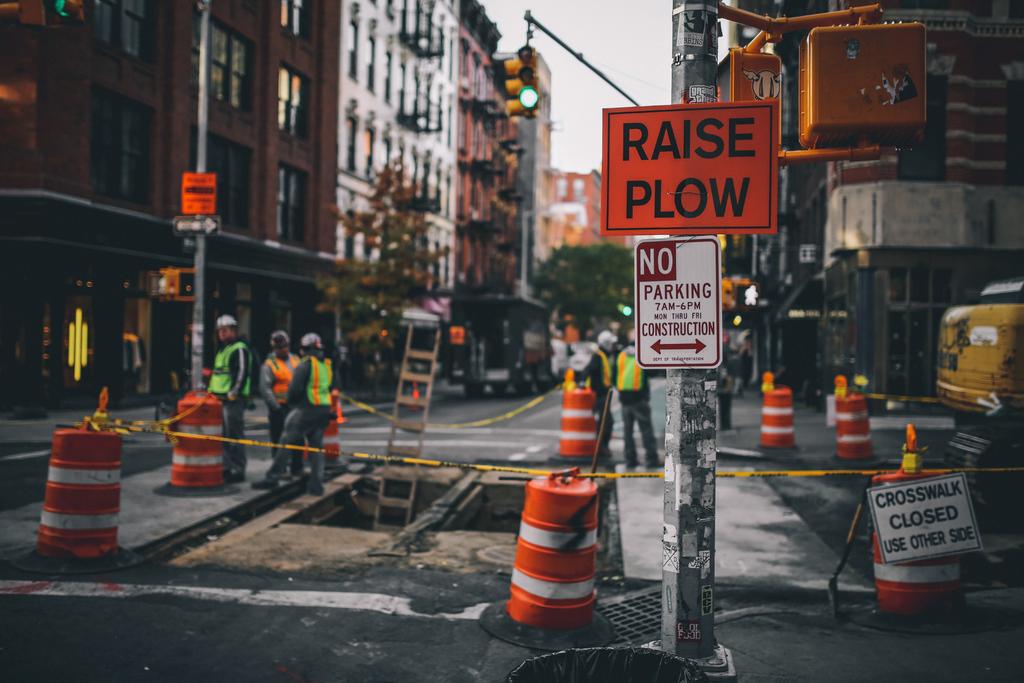What does the orange sign say?
Offer a terse response. Raise plow. 